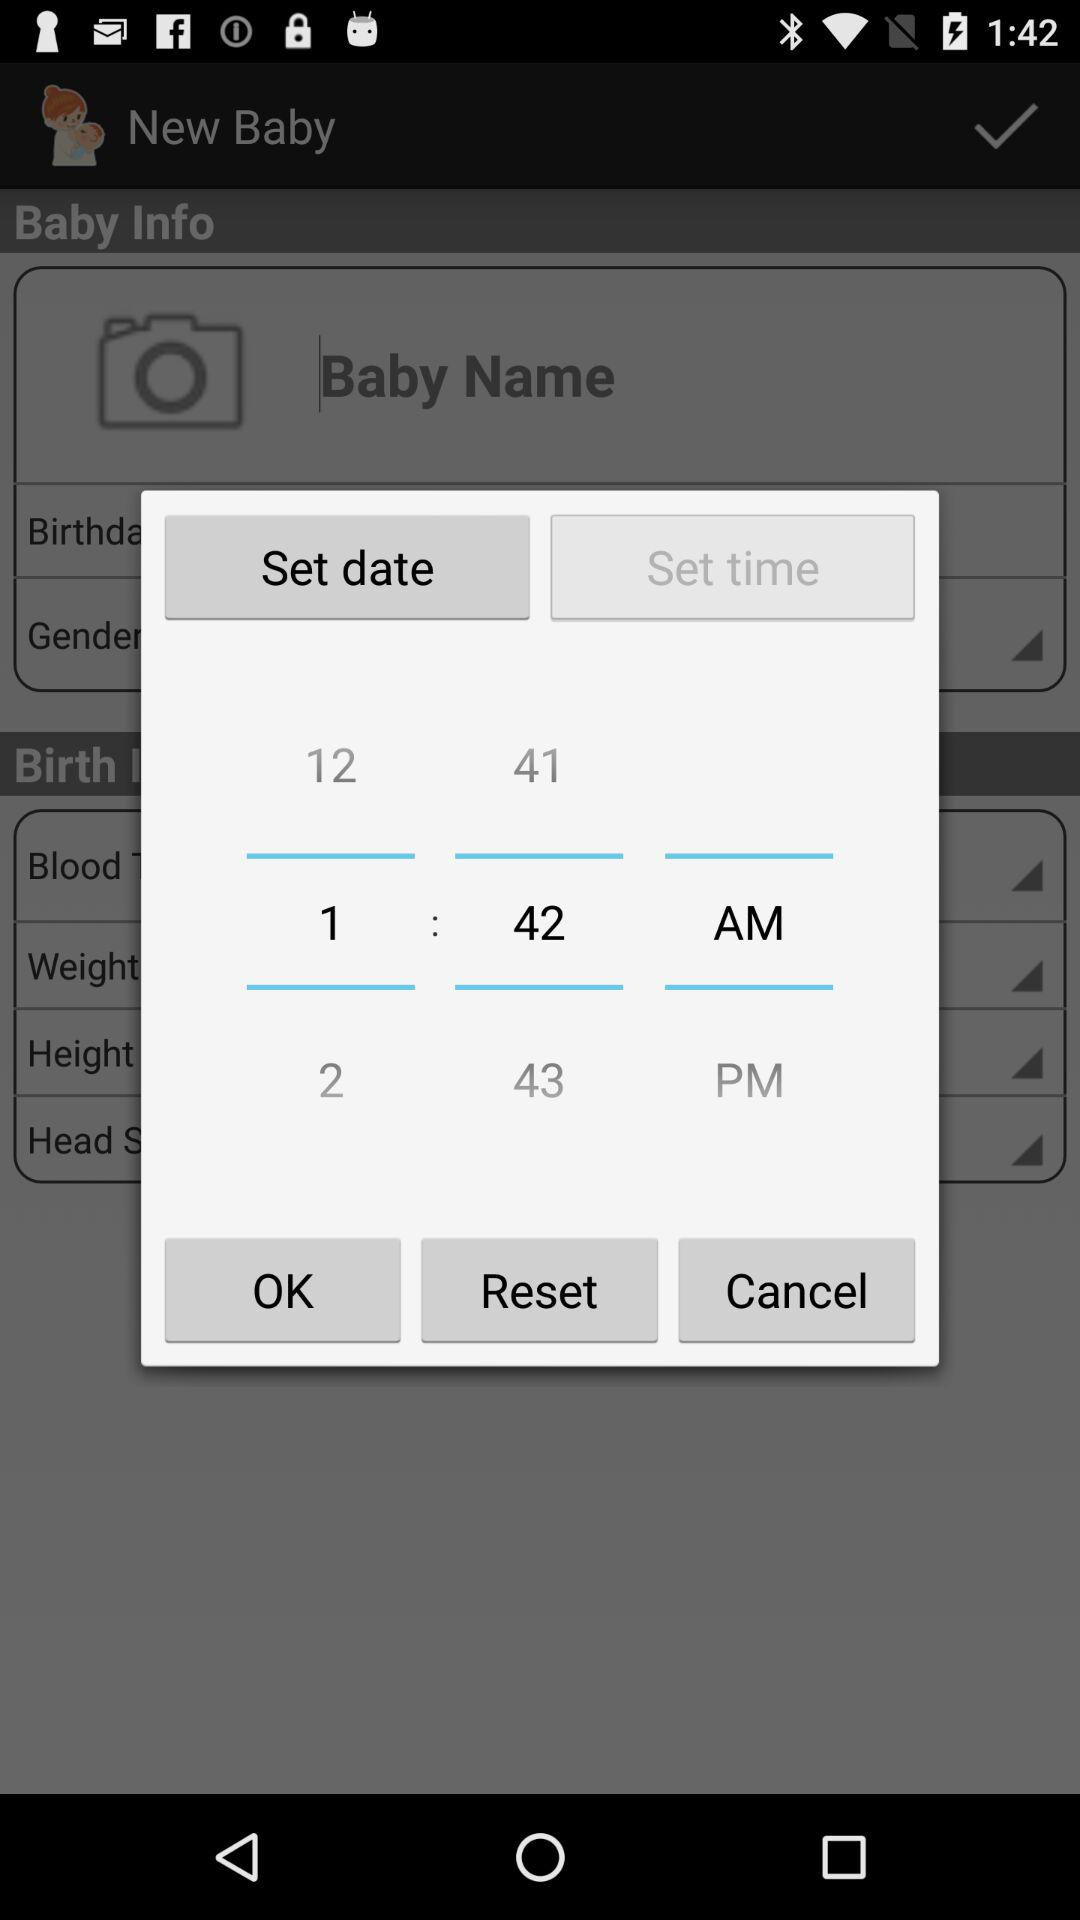What time is set? The set time is 1:42 a.m. 